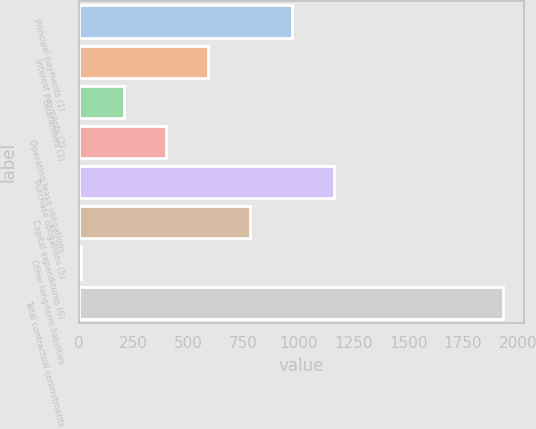Convert chart. <chart><loc_0><loc_0><loc_500><loc_500><bar_chart><fcel>Principal payments (1)<fcel>Interest payments (2)<fcel>Guarantees (3)<fcel>Operating lease obligations<fcel>Purchase obligations (5)<fcel>Capital expenditures (6)<fcel>Other long-term liabilities<fcel>Total contractual commitments<nl><fcel>971.5<fcel>587.7<fcel>203.9<fcel>395.8<fcel>1163.4<fcel>779.6<fcel>12<fcel>1931<nl></chart> 